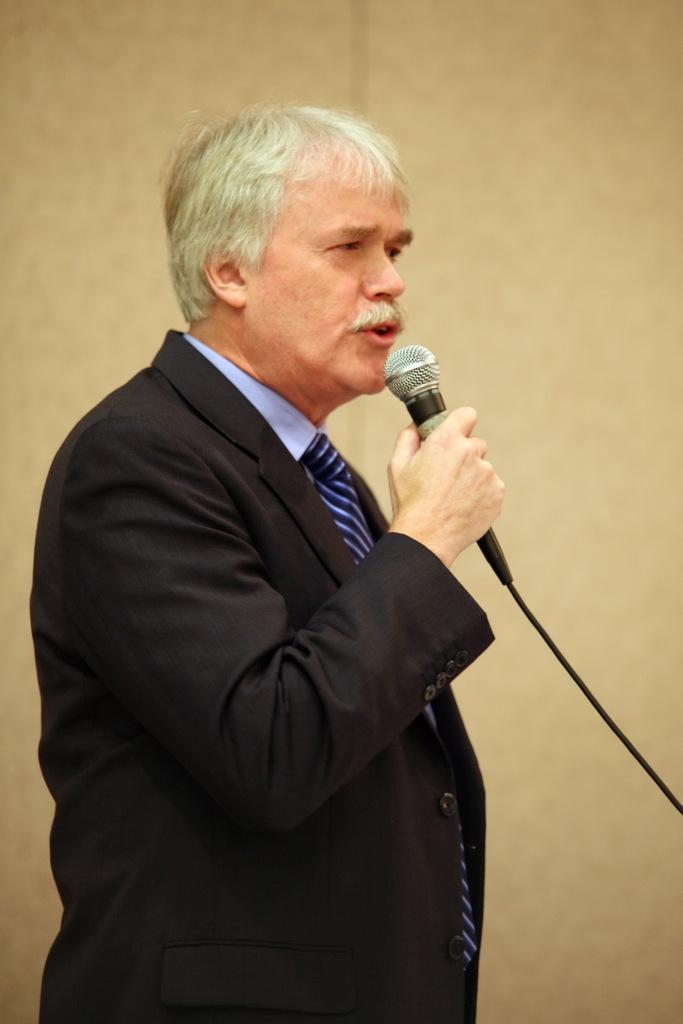Describe this image in one or two sentences. Here we can see a person is standing and holding a microphone in his hands, and at back here is the wall. 